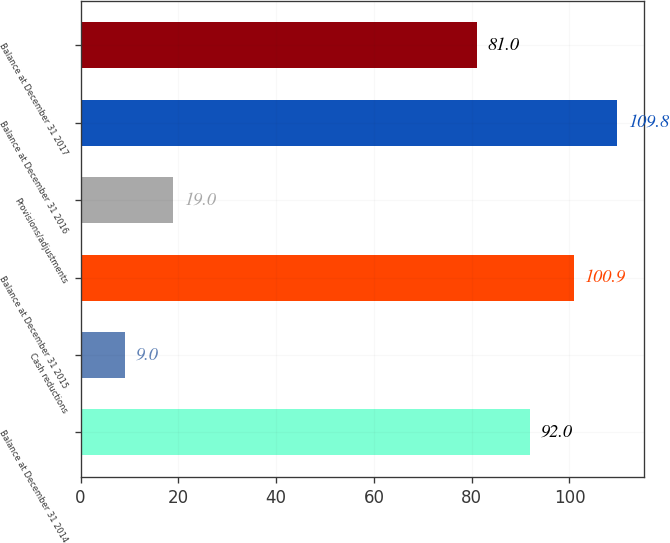Convert chart to OTSL. <chart><loc_0><loc_0><loc_500><loc_500><bar_chart><fcel>Balance at December 31 2014<fcel>Cash reductions<fcel>Balance at December 31 2015<fcel>Provisions/adjustments<fcel>Balance at December 31 2016<fcel>Balance at December 31 2017<nl><fcel>92<fcel>9<fcel>100.9<fcel>19<fcel>109.8<fcel>81<nl></chart> 